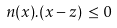<formula> <loc_0><loc_0><loc_500><loc_500>n ( x ) . ( x - z ) \, \leq 0</formula> 